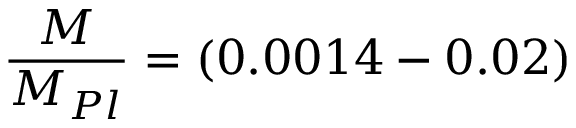Convert formula to latex. <formula><loc_0><loc_0><loc_500><loc_500>\frac { M } { M _ { P l } } = ( 0 . 0 0 1 4 - 0 . 0 2 )</formula> 